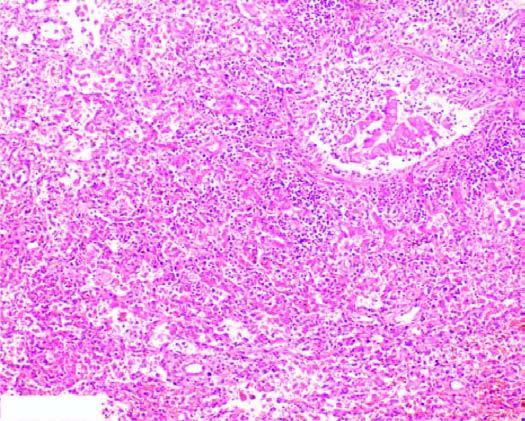what are filled with exudate consisting chiefly of neutrophils?
Answer the question using a single word or phrase. Bronchioles as well as the adjacent alveoli 